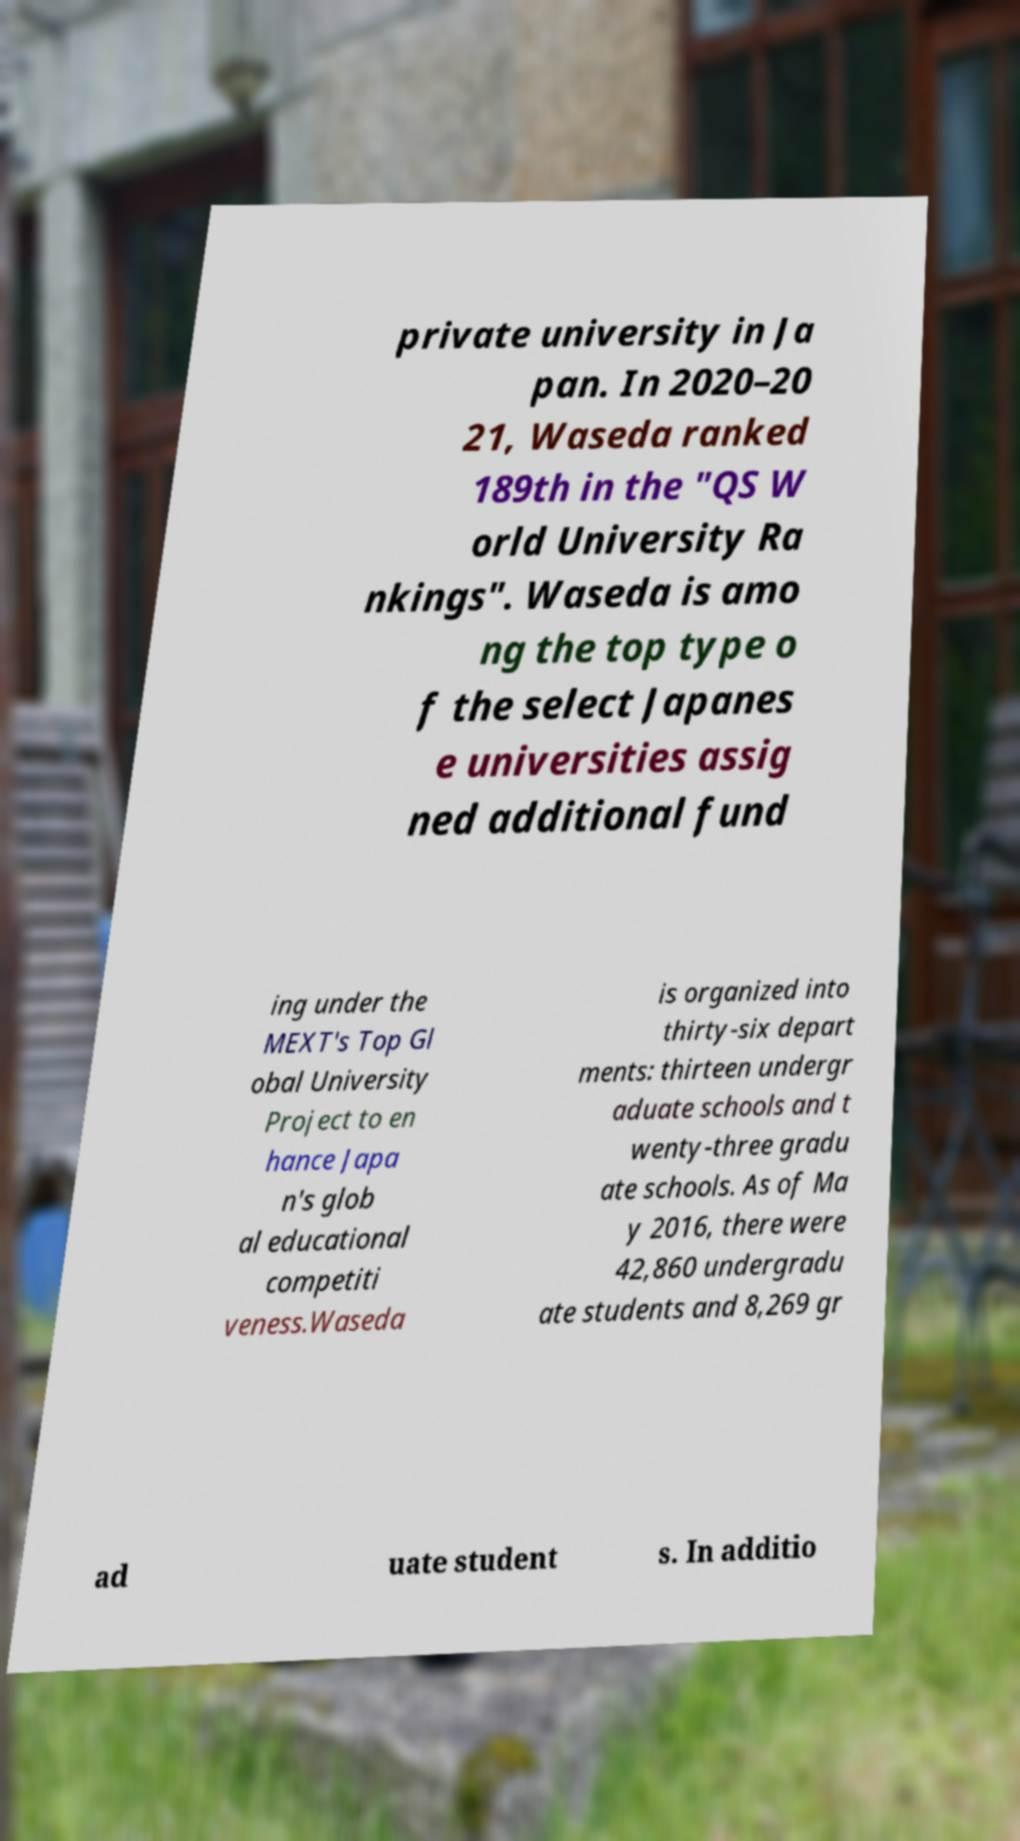For documentation purposes, I need the text within this image transcribed. Could you provide that? private university in Ja pan. In 2020–20 21, Waseda ranked 189th in the "QS W orld University Ra nkings". Waseda is amo ng the top type o f the select Japanes e universities assig ned additional fund ing under the MEXT's Top Gl obal University Project to en hance Japa n's glob al educational competiti veness.Waseda is organized into thirty-six depart ments: thirteen undergr aduate schools and t wenty-three gradu ate schools. As of Ma y 2016, there were 42,860 undergradu ate students and 8,269 gr ad uate student s. In additio 